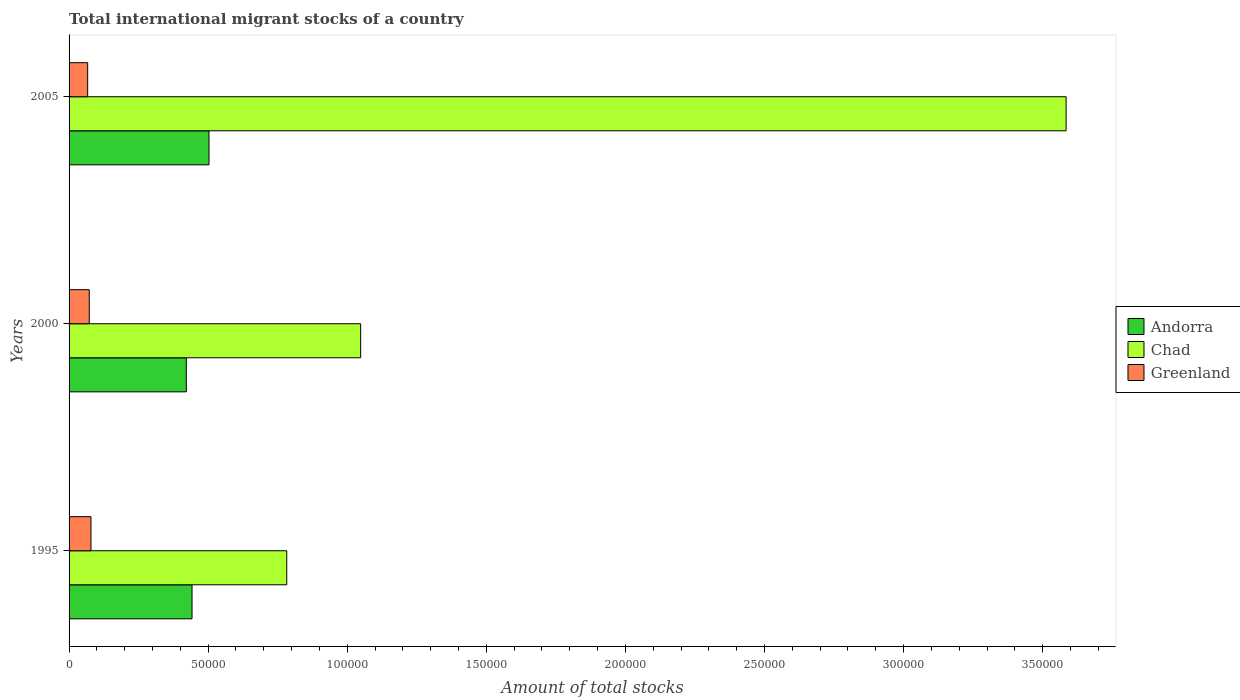How many groups of bars are there?
Your answer should be compact. 3. Are the number of bars per tick equal to the number of legend labels?
Ensure brevity in your answer.  Yes. How many bars are there on the 1st tick from the bottom?
Make the answer very short. 3. What is the label of the 1st group of bars from the top?
Offer a very short reply. 2005. In how many cases, is the number of bars for a given year not equal to the number of legend labels?
Ensure brevity in your answer.  0. What is the amount of total stocks in in Andorra in 2000?
Give a very brief answer. 4.21e+04. Across all years, what is the maximum amount of total stocks in in Greenland?
Offer a very short reply. 7875. Across all years, what is the minimum amount of total stocks in in Andorra?
Your answer should be very brief. 4.21e+04. In which year was the amount of total stocks in in Chad maximum?
Offer a terse response. 2005. What is the total amount of total stocks in in Chad in the graph?
Provide a short and direct response. 5.42e+05. What is the difference between the amount of total stocks in in Chad in 1995 and that in 2005?
Your answer should be compact. -2.80e+05. What is the difference between the amount of total stocks in in Chad in 2005 and the amount of total stocks in in Greenland in 1995?
Make the answer very short. 3.51e+05. What is the average amount of total stocks in in Andorra per year?
Give a very brief answer. 4.56e+04. In the year 2005, what is the difference between the amount of total stocks in in Andorra and amount of total stocks in in Greenland?
Offer a very short reply. 4.36e+04. In how many years, is the amount of total stocks in in Chad greater than 290000 ?
Ensure brevity in your answer.  1. What is the ratio of the amount of total stocks in in Chad in 2000 to that in 2005?
Give a very brief answer. 0.29. What is the difference between the highest and the second highest amount of total stocks in in Andorra?
Give a very brief answer. 6098. What is the difference between the highest and the lowest amount of total stocks in in Chad?
Keep it short and to the point. 2.80e+05. Is the sum of the amount of total stocks in in Greenland in 2000 and 2005 greater than the maximum amount of total stocks in in Chad across all years?
Keep it short and to the point. No. What does the 3rd bar from the top in 2005 represents?
Provide a short and direct response. Andorra. What does the 3rd bar from the bottom in 2000 represents?
Your answer should be compact. Greenland. Is it the case that in every year, the sum of the amount of total stocks in in Greenland and amount of total stocks in in Chad is greater than the amount of total stocks in in Andorra?
Give a very brief answer. Yes. How many bars are there?
Provide a succinct answer. 9. What is the difference between two consecutive major ticks on the X-axis?
Your response must be concise. 5.00e+04. Are the values on the major ticks of X-axis written in scientific E-notation?
Keep it short and to the point. No. How are the legend labels stacked?
Your answer should be very brief. Vertical. What is the title of the graph?
Keep it short and to the point. Total international migrant stocks of a country. What is the label or title of the X-axis?
Give a very brief answer. Amount of total stocks. What is the Amount of total stocks of Andorra in 1995?
Ensure brevity in your answer.  4.42e+04. What is the Amount of total stocks in Chad in 1995?
Give a very brief answer. 7.83e+04. What is the Amount of total stocks of Greenland in 1995?
Offer a very short reply. 7875. What is the Amount of total stocks of Andorra in 2000?
Provide a short and direct response. 4.21e+04. What is the Amount of total stocks of Chad in 2000?
Give a very brief answer. 1.05e+05. What is the Amount of total stocks in Greenland in 2000?
Make the answer very short. 7256. What is the Amount of total stocks of Andorra in 2005?
Your answer should be very brief. 5.03e+04. What is the Amount of total stocks of Chad in 2005?
Your answer should be compact. 3.58e+05. What is the Amount of total stocks in Greenland in 2005?
Provide a short and direct response. 6685. Across all years, what is the maximum Amount of total stocks of Andorra?
Offer a terse response. 5.03e+04. Across all years, what is the maximum Amount of total stocks of Chad?
Ensure brevity in your answer.  3.58e+05. Across all years, what is the maximum Amount of total stocks of Greenland?
Your answer should be compact. 7875. Across all years, what is the minimum Amount of total stocks of Andorra?
Provide a short and direct response. 4.21e+04. Across all years, what is the minimum Amount of total stocks of Chad?
Make the answer very short. 7.83e+04. Across all years, what is the minimum Amount of total stocks of Greenland?
Make the answer very short. 6685. What is the total Amount of total stocks in Andorra in the graph?
Offer a terse response. 1.37e+05. What is the total Amount of total stocks in Chad in the graph?
Your response must be concise. 5.42e+05. What is the total Amount of total stocks of Greenland in the graph?
Your answer should be very brief. 2.18e+04. What is the difference between the Amount of total stocks of Andorra in 1995 and that in 2000?
Your response must be concise. 2059. What is the difference between the Amount of total stocks of Chad in 1995 and that in 2000?
Offer a terse response. -2.66e+04. What is the difference between the Amount of total stocks in Greenland in 1995 and that in 2000?
Offer a very short reply. 619. What is the difference between the Amount of total stocks in Andorra in 1995 and that in 2005?
Make the answer very short. -6098. What is the difference between the Amount of total stocks in Chad in 1995 and that in 2005?
Give a very brief answer. -2.80e+05. What is the difference between the Amount of total stocks of Greenland in 1995 and that in 2005?
Your answer should be compact. 1190. What is the difference between the Amount of total stocks of Andorra in 2000 and that in 2005?
Keep it short and to the point. -8157. What is the difference between the Amount of total stocks in Chad in 2000 and that in 2005?
Make the answer very short. -2.54e+05. What is the difference between the Amount of total stocks in Greenland in 2000 and that in 2005?
Provide a short and direct response. 571. What is the difference between the Amount of total stocks of Andorra in 1995 and the Amount of total stocks of Chad in 2000?
Your answer should be very brief. -6.06e+04. What is the difference between the Amount of total stocks of Andorra in 1995 and the Amount of total stocks of Greenland in 2000?
Give a very brief answer. 3.69e+04. What is the difference between the Amount of total stocks of Chad in 1995 and the Amount of total stocks of Greenland in 2000?
Make the answer very short. 7.10e+04. What is the difference between the Amount of total stocks in Andorra in 1995 and the Amount of total stocks in Chad in 2005?
Provide a short and direct response. -3.14e+05. What is the difference between the Amount of total stocks in Andorra in 1995 and the Amount of total stocks in Greenland in 2005?
Offer a very short reply. 3.75e+04. What is the difference between the Amount of total stocks in Chad in 1995 and the Amount of total stocks in Greenland in 2005?
Ensure brevity in your answer.  7.16e+04. What is the difference between the Amount of total stocks in Andorra in 2000 and the Amount of total stocks in Chad in 2005?
Offer a very short reply. -3.16e+05. What is the difference between the Amount of total stocks of Andorra in 2000 and the Amount of total stocks of Greenland in 2005?
Your answer should be very brief. 3.55e+04. What is the difference between the Amount of total stocks in Chad in 2000 and the Amount of total stocks in Greenland in 2005?
Your answer should be compact. 9.81e+04. What is the average Amount of total stocks of Andorra per year?
Give a very brief answer. 4.56e+04. What is the average Amount of total stocks of Chad per year?
Offer a very short reply. 1.81e+05. What is the average Amount of total stocks of Greenland per year?
Make the answer very short. 7272. In the year 1995, what is the difference between the Amount of total stocks of Andorra and Amount of total stocks of Chad?
Keep it short and to the point. -3.41e+04. In the year 1995, what is the difference between the Amount of total stocks in Andorra and Amount of total stocks in Greenland?
Offer a very short reply. 3.63e+04. In the year 1995, what is the difference between the Amount of total stocks in Chad and Amount of total stocks in Greenland?
Give a very brief answer. 7.04e+04. In the year 2000, what is the difference between the Amount of total stocks of Andorra and Amount of total stocks of Chad?
Provide a succinct answer. -6.27e+04. In the year 2000, what is the difference between the Amount of total stocks in Andorra and Amount of total stocks in Greenland?
Offer a terse response. 3.49e+04. In the year 2000, what is the difference between the Amount of total stocks of Chad and Amount of total stocks of Greenland?
Give a very brief answer. 9.76e+04. In the year 2005, what is the difference between the Amount of total stocks in Andorra and Amount of total stocks in Chad?
Give a very brief answer. -3.08e+05. In the year 2005, what is the difference between the Amount of total stocks of Andorra and Amount of total stocks of Greenland?
Provide a succinct answer. 4.36e+04. In the year 2005, what is the difference between the Amount of total stocks of Chad and Amount of total stocks of Greenland?
Your answer should be very brief. 3.52e+05. What is the ratio of the Amount of total stocks of Andorra in 1995 to that in 2000?
Ensure brevity in your answer.  1.05. What is the ratio of the Amount of total stocks in Chad in 1995 to that in 2000?
Provide a succinct answer. 0.75. What is the ratio of the Amount of total stocks of Greenland in 1995 to that in 2000?
Provide a succinct answer. 1.09. What is the ratio of the Amount of total stocks of Andorra in 1995 to that in 2005?
Provide a succinct answer. 0.88. What is the ratio of the Amount of total stocks of Chad in 1995 to that in 2005?
Your answer should be very brief. 0.22. What is the ratio of the Amount of total stocks in Greenland in 1995 to that in 2005?
Your answer should be very brief. 1.18. What is the ratio of the Amount of total stocks of Andorra in 2000 to that in 2005?
Make the answer very short. 0.84. What is the ratio of the Amount of total stocks in Chad in 2000 to that in 2005?
Your answer should be compact. 0.29. What is the ratio of the Amount of total stocks in Greenland in 2000 to that in 2005?
Ensure brevity in your answer.  1.09. What is the difference between the highest and the second highest Amount of total stocks in Andorra?
Provide a succinct answer. 6098. What is the difference between the highest and the second highest Amount of total stocks in Chad?
Provide a short and direct response. 2.54e+05. What is the difference between the highest and the second highest Amount of total stocks of Greenland?
Give a very brief answer. 619. What is the difference between the highest and the lowest Amount of total stocks in Andorra?
Ensure brevity in your answer.  8157. What is the difference between the highest and the lowest Amount of total stocks in Chad?
Give a very brief answer. 2.80e+05. What is the difference between the highest and the lowest Amount of total stocks of Greenland?
Your answer should be compact. 1190. 